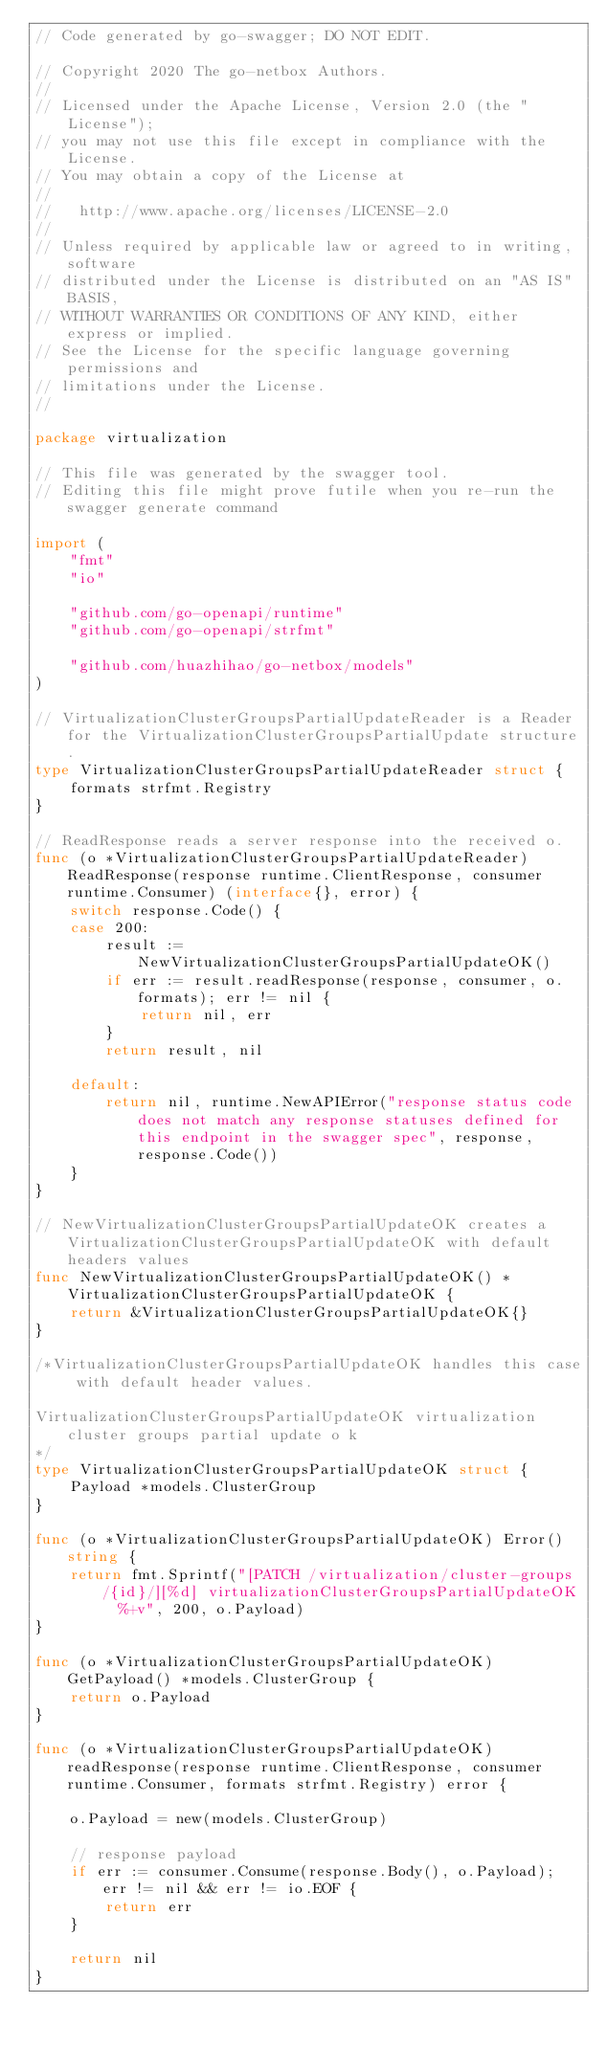<code> <loc_0><loc_0><loc_500><loc_500><_Go_>// Code generated by go-swagger; DO NOT EDIT.

// Copyright 2020 The go-netbox Authors.
//
// Licensed under the Apache License, Version 2.0 (the "License");
// you may not use this file except in compliance with the License.
// You may obtain a copy of the License at
//
//   http://www.apache.org/licenses/LICENSE-2.0
//
// Unless required by applicable law or agreed to in writing, software
// distributed under the License is distributed on an "AS IS" BASIS,
// WITHOUT WARRANTIES OR CONDITIONS OF ANY KIND, either express or implied.
// See the License for the specific language governing permissions and
// limitations under the License.
//

package virtualization

// This file was generated by the swagger tool.
// Editing this file might prove futile when you re-run the swagger generate command

import (
	"fmt"
	"io"

	"github.com/go-openapi/runtime"
	"github.com/go-openapi/strfmt"

	"github.com/huazhihao/go-netbox/models"
)

// VirtualizationClusterGroupsPartialUpdateReader is a Reader for the VirtualizationClusterGroupsPartialUpdate structure.
type VirtualizationClusterGroupsPartialUpdateReader struct {
	formats strfmt.Registry
}

// ReadResponse reads a server response into the received o.
func (o *VirtualizationClusterGroupsPartialUpdateReader) ReadResponse(response runtime.ClientResponse, consumer runtime.Consumer) (interface{}, error) {
	switch response.Code() {
	case 200:
		result := NewVirtualizationClusterGroupsPartialUpdateOK()
		if err := result.readResponse(response, consumer, o.formats); err != nil {
			return nil, err
		}
		return result, nil

	default:
		return nil, runtime.NewAPIError("response status code does not match any response statuses defined for this endpoint in the swagger spec", response, response.Code())
	}
}

// NewVirtualizationClusterGroupsPartialUpdateOK creates a VirtualizationClusterGroupsPartialUpdateOK with default headers values
func NewVirtualizationClusterGroupsPartialUpdateOK() *VirtualizationClusterGroupsPartialUpdateOK {
	return &VirtualizationClusterGroupsPartialUpdateOK{}
}

/*VirtualizationClusterGroupsPartialUpdateOK handles this case with default header values.

VirtualizationClusterGroupsPartialUpdateOK virtualization cluster groups partial update o k
*/
type VirtualizationClusterGroupsPartialUpdateOK struct {
	Payload *models.ClusterGroup
}

func (o *VirtualizationClusterGroupsPartialUpdateOK) Error() string {
	return fmt.Sprintf("[PATCH /virtualization/cluster-groups/{id}/][%d] virtualizationClusterGroupsPartialUpdateOK  %+v", 200, o.Payload)
}

func (o *VirtualizationClusterGroupsPartialUpdateOK) GetPayload() *models.ClusterGroup {
	return o.Payload
}

func (o *VirtualizationClusterGroupsPartialUpdateOK) readResponse(response runtime.ClientResponse, consumer runtime.Consumer, formats strfmt.Registry) error {

	o.Payload = new(models.ClusterGroup)

	// response payload
	if err := consumer.Consume(response.Body(), o.Payload); err != nil && err != io.EOF {
		return err
	}

	return nil
}
</code> 